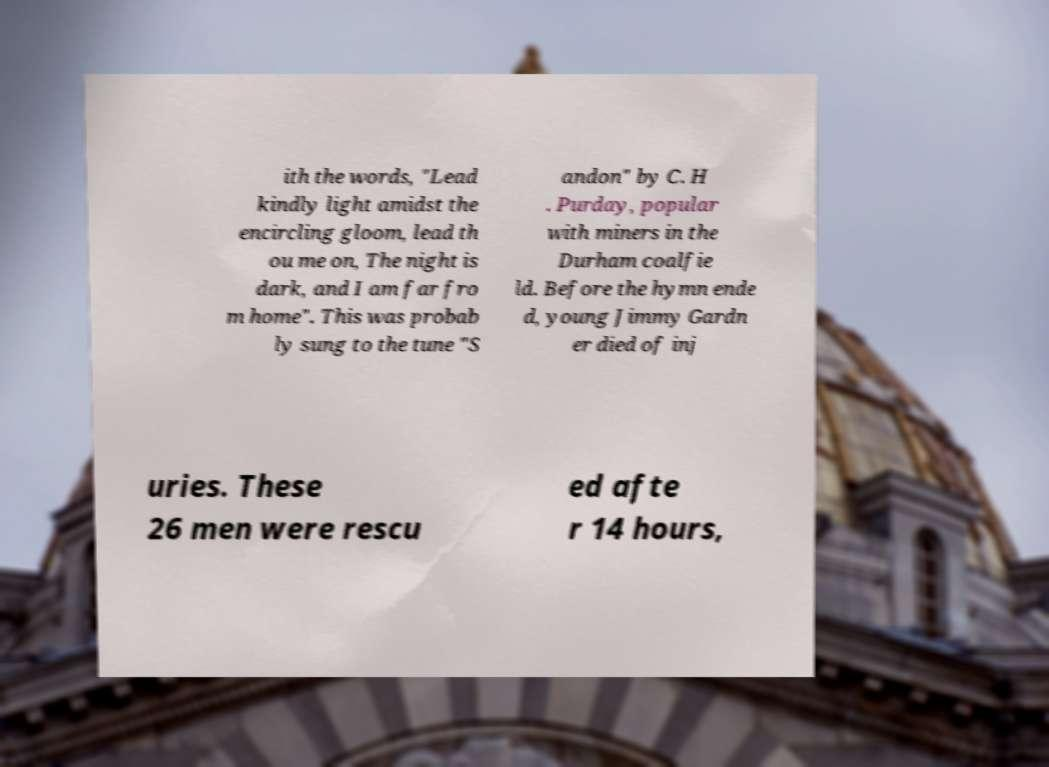I need the written content from this picture converted into text. Can you do that? ith the words, "Lead kindly light amidst the encircling gloom, lead th ou me on, The night is dark, and I am far fro m home". This was probab ly sung to the tune "S andon" by C. H . Purday, popular with miners in the Durham coalfie ld. Before the hymn ende d, young Jimmy Gardn er died of inj uries. These 26 men were rescu ed afte r 14 hours, 